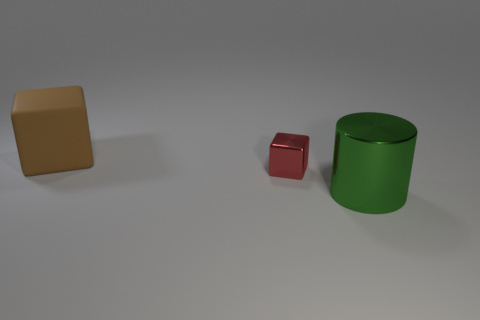Is there any other thing that is the same size as the red block?
Keep it short and to the point. No. How many red shiny cubes are behind the small red thing?
Offer a very short reply. 0. How many metallic cubes are the same color as the large rubber block?
Provide a short and direct response. 0. Do the large object on the right side of the metallic block and the tiny red cube have the same material?
Give a very brief answer. Yes. How many small red things are made of the same material as the green thing?
Provide a short and direct response. 1. Is the number of red metallic blocks on the right side of the brown rubber block greater than the number of yellow metal balls?
Your answer should be compact. Yes. Are there any small objects that have the same shape as the large matte object?
Ensure brevity in your answer.  Yes. How many objects are either big objects or red metallic objects?
Your answer should be very brief. 3. What number of big brown rubber blocks are behind the metallic thing behind the big thing that is in front of the brown rubber object?
Your answer should be very brief. 1. What material is the brown thing that is the same shape as the small red metallic object?
Your answer should be compact. Rubber. 